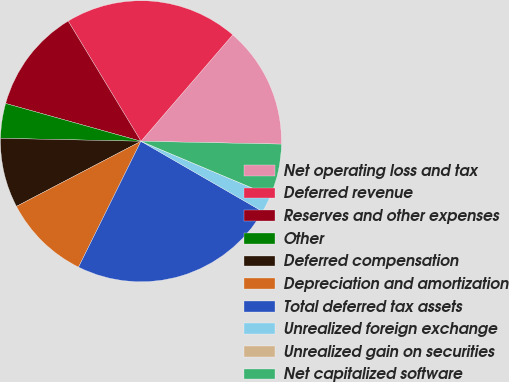Convert chart. <chart><loc_0><loc_0><loc_500><loc_500><pie_chart><fcel>Net operating loss and tax<fcel>Deferred revenue<fcel>Reserves and other expenses<fcel>Other<fcel>Deferred compensation<fcel>Depreciation and amortization<fcel>Total deferred tax assets<fcel>Unrealized foreign exchange<fcel>Unrealized gain on securities<fcel>Net capitalized software<nl><fcel>14.0%<fcel>19.99%<fcel>12.0%<fcel>4.0%<fcel>8.0%<fcel>10.0%<fcel>23.99%<fcel>2.0%<fcel>0.01%<fcel>6.0%<nl></chart> 